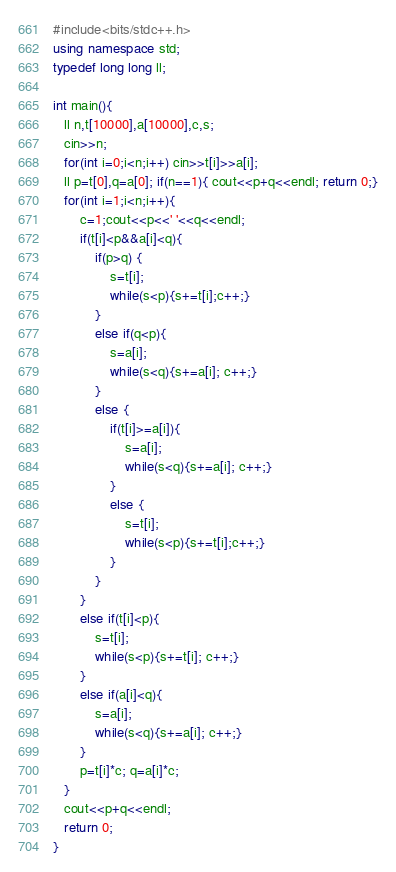<code> <loc_0><loc_0><loc_500><loc_500><_C++_>#include<bits/stdc++.h>
using namespace std;
typedef long long ll;
 
int main(){
   ll n,t[10000],a[10000],c,s;
   cin>>n;
   for(int i=0;i<n;i++) cin>>t[i]>>a[i];
   ll p=t[0],q=a[0]; if(n==1){ cout<<p+q<<endl; return 0;}
   for(int i=1;i<n;i++){
       c=1;cout<<p<<' '<<q<<endl;
       if(t[i]<p&&a[i]<q){
           if(p>q) {
               s=t[i];
               while(s<p){s+=t[i];c++;}
           }
           else if(q<p){ 
               s=a[i];
               while(s<q){s+=a[i]; c++;}
           }
           else { 
               if(t[i]>=a[i]){
                   s=a[i];
                   while(s<q){s+=a[i]; c++;}
               }
               else {
                   s=t[i];
                   while(s<p){s+=t[i];c++;}
               }
           }
       }
       else if(t[i]<p){
           s=t[i];
           while(s<p){s+=t[i]; c++;}
       }
       else if(a[i]<q){
           s=a[i];
           while(s<q){s+=a[i]; c++;}
       }
       p=t[i]*c; q=a[i]*c;
   }
   cout<<p+q<<endl;
   return 0;
}</code> 